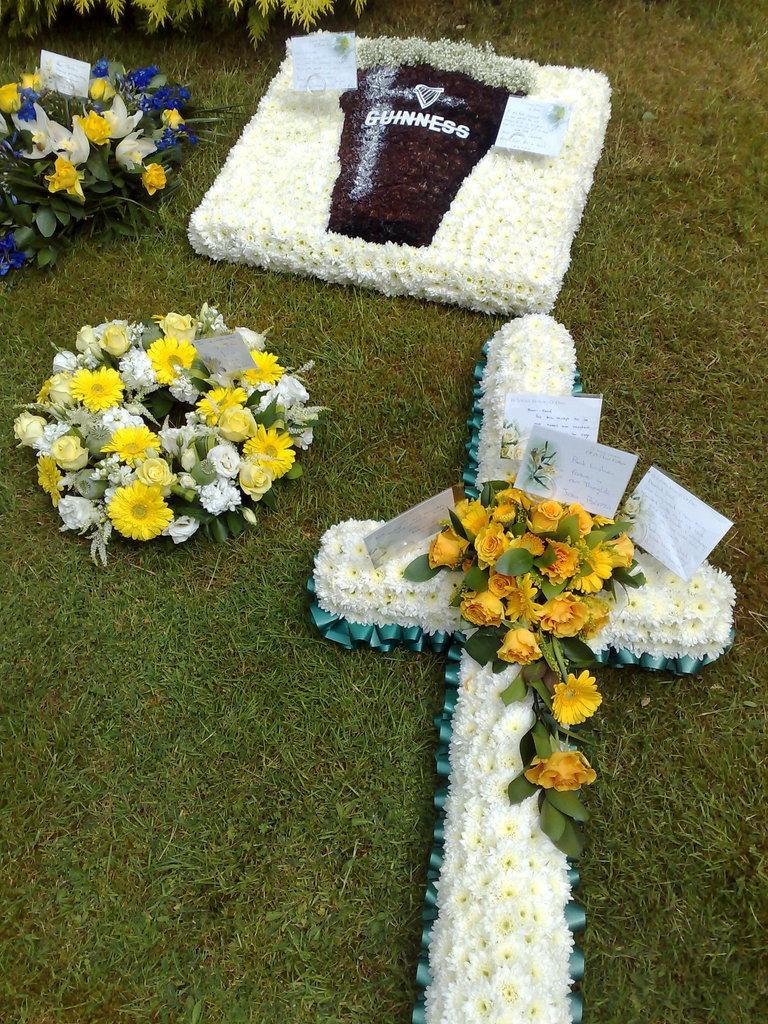Describe this image in one or two sentences. In this image we can see few bouquets placed on grass. On the bouquet we can see few cards. At the top we can see leaves. 